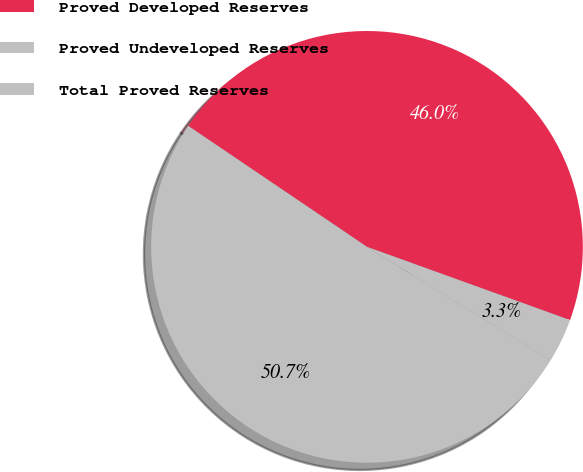Convert chart. <chart><loc_0><loc_0><loc_500><loc_500><pie_chart><fcel>Proved Developed Reserves<fcel>Proved Undeveloped Reserves<fcel>Total Proved Reserves<nl><fcel>46.04%<fcel>3.31%<fcel>50.65%<nl></chart> 